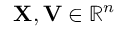<formula> <loc_0><loc_0><loc_500><loc_500>X , V \in \mathbb { R } ^ { n }</formula> 